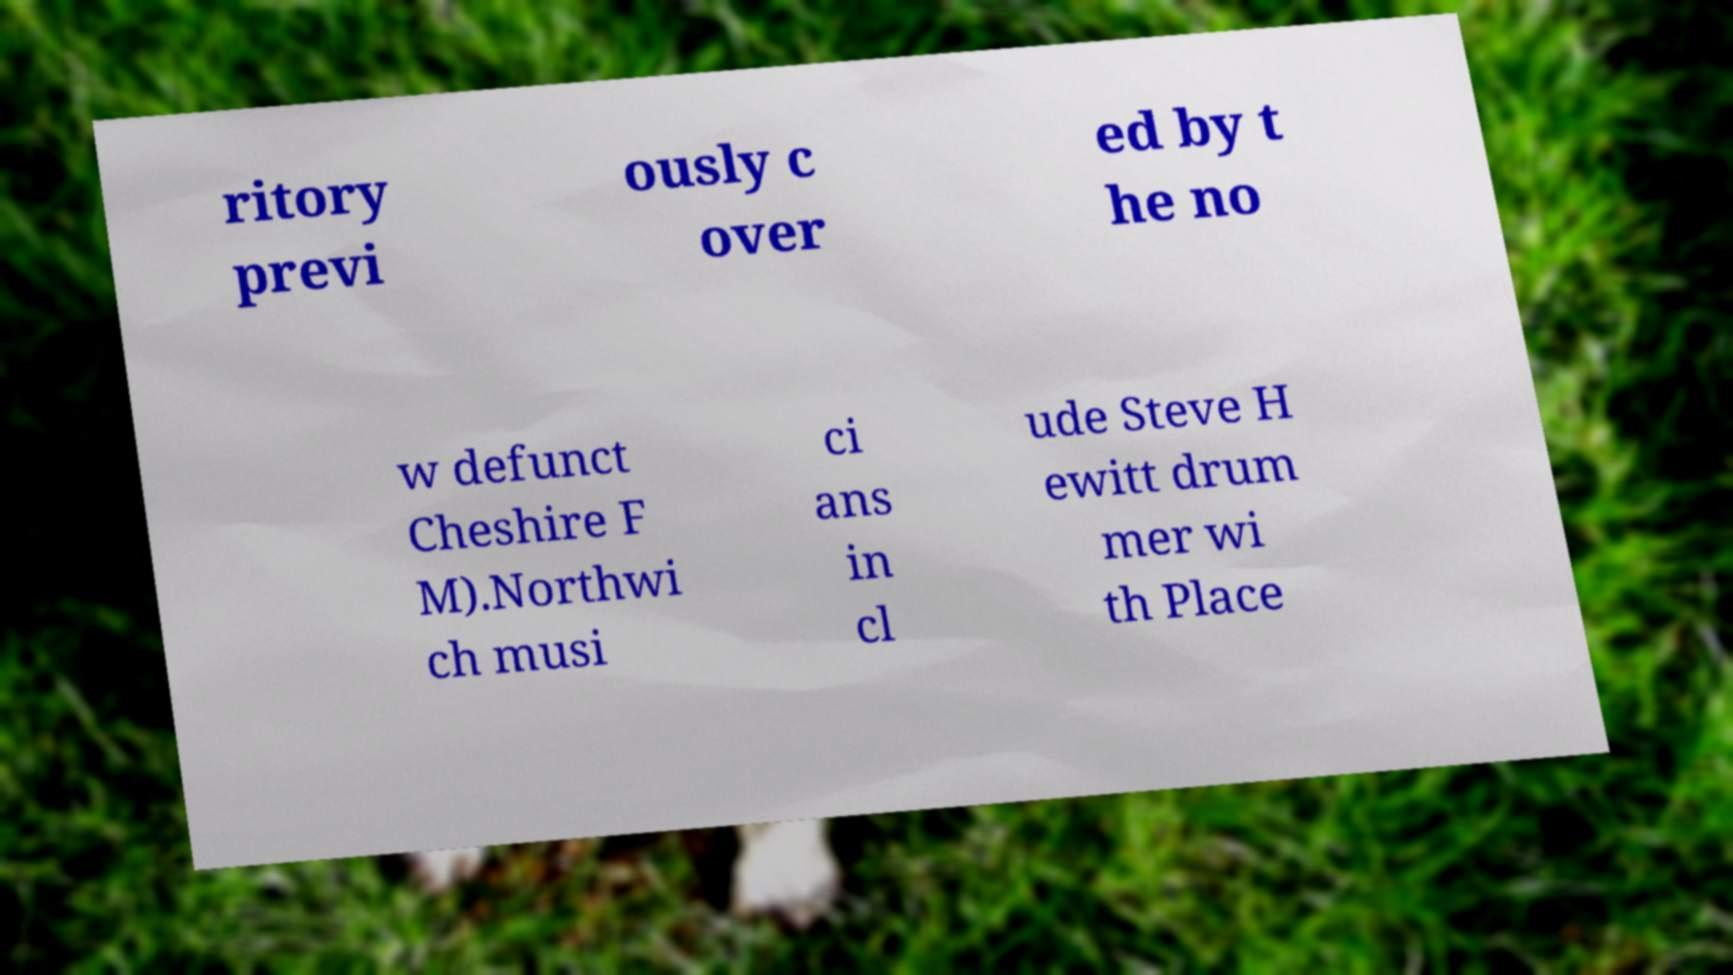Please read and relay the text visible in this image. What does it say? ritory previ ously c over ed by t he no w defunct Cheshire F M).Northwi ch musi ci ans in cl ude Steve H ewitt drum mer wi th Place 